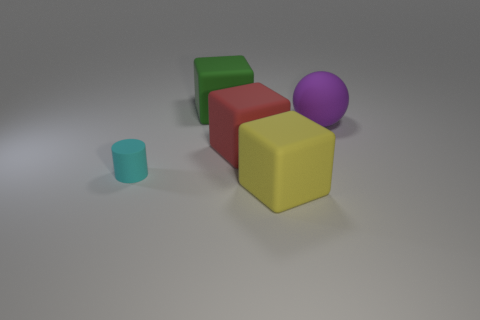Add 4 green things. How many objects exist? 9 Subtract all big green rubber cubes. How many cubes are left? 2 Subtract 1 cubes. How many cubes are left? 2 Subtract all spheres. How many objects are left? 4 Add 3 gray metal balls. How many gray metal balls exist? 3 Subtract 0 brown cubes. How many objects are left? 5 Subtract all blue balls. Subtract all purple cylinders. How many balls are left? 1 Subtract all small gray metal cylinders. Subtract all small cyan cylinders. How many objects are left? 4 Add 2 large green matte cubes. How many large green matte cubes are left? 3 